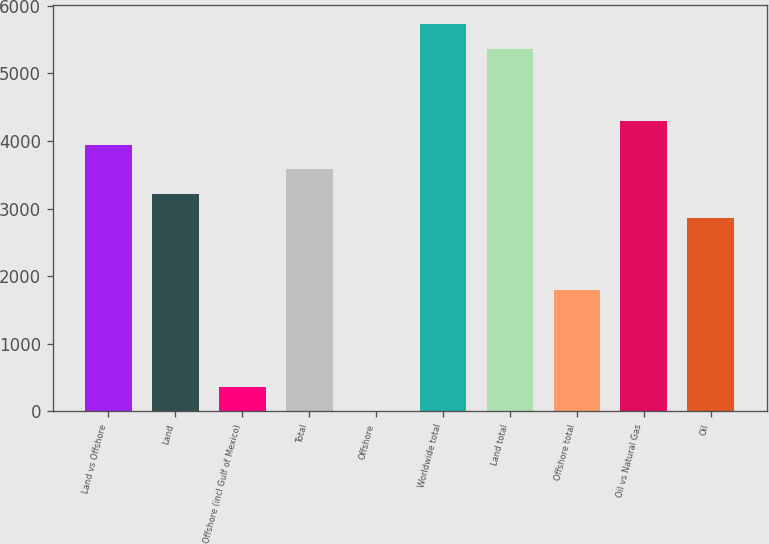<chart> <loc_0><loc_0><loc_500><loc_500><bar_chart><fcel>Land vs Offshore<fcel>Land<fcel>Offshore (incl Gulf of Mexico)<fcel>Total<fcel>Offshore<fcel>Worldwide total<fcel>Land total<fcel>Offshore total<fcel>Oil vs Natural Gas<fcel>Oil<nl><fcel>3935.6<fcel>3220.4<fcel>359.6<fcel>3578<fcel>2<fcel>5723.6<fcel>5366<fcel>1790<fcel>4293.2<fcel>2862.8<nl></chart> 